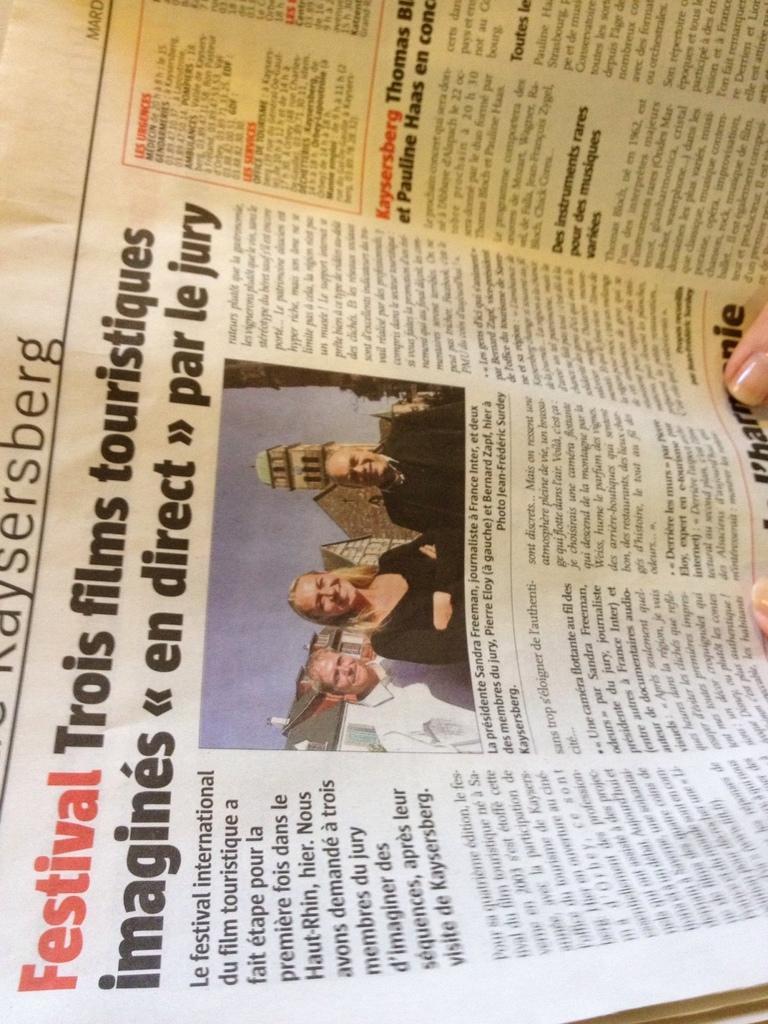Could you give a brief overview of what you see in this image? This picture contains an English newspaper. On the left side of the picture, we see text written in highlighted words. In the middle of the picture, we see three people standing and all of them are smiling. Behind them, we see a monument. We see some text written on the newspaper. On the right side, we see the fingers of the hand. 